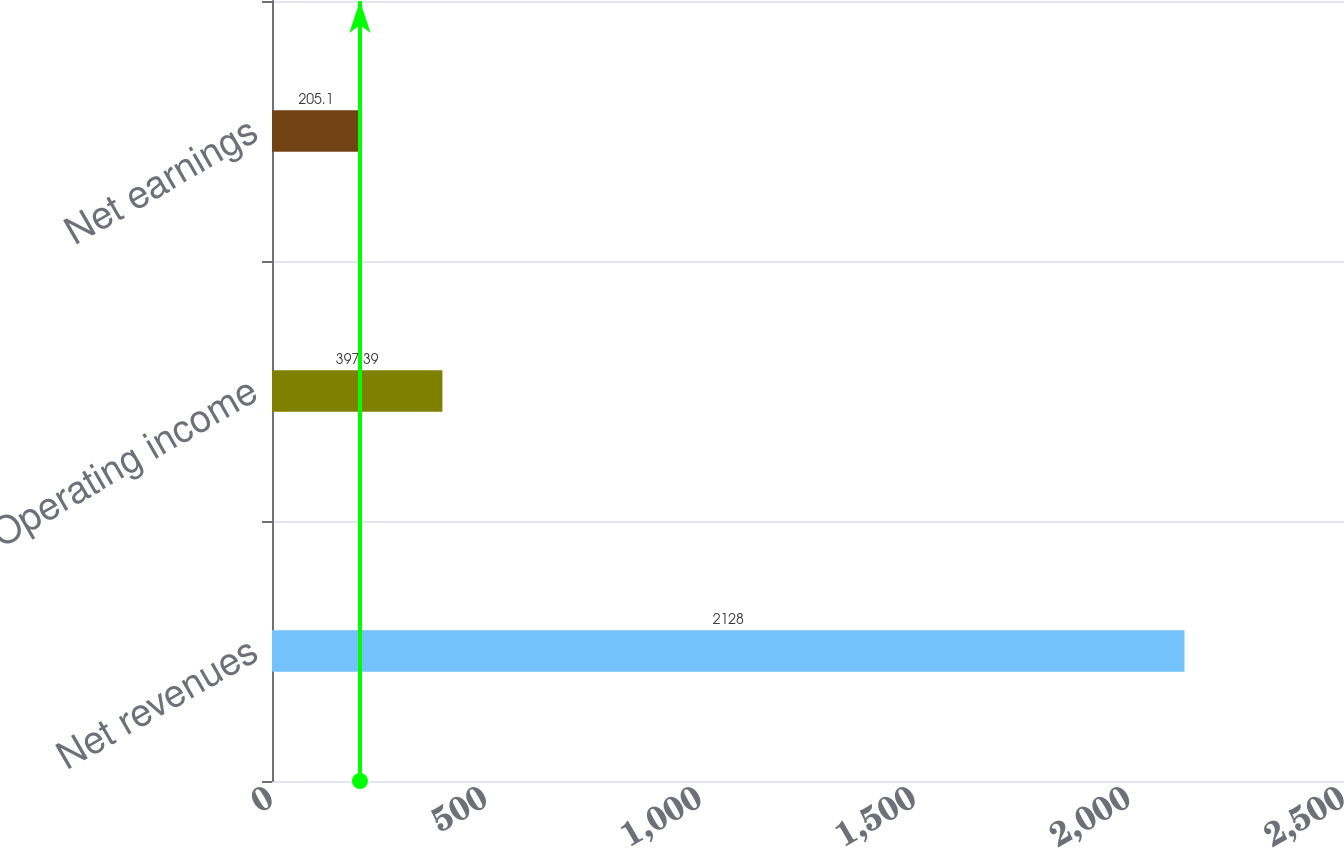Convert chart. <chart><loc_0><loc_0><loc_500><loc_500><bar_chart><fcel>Net revenues<fcel>Operating income<fcel>Net earnings<nl><fcel>2128<fcel>397.39<fcel>205.1<nl></chart> 